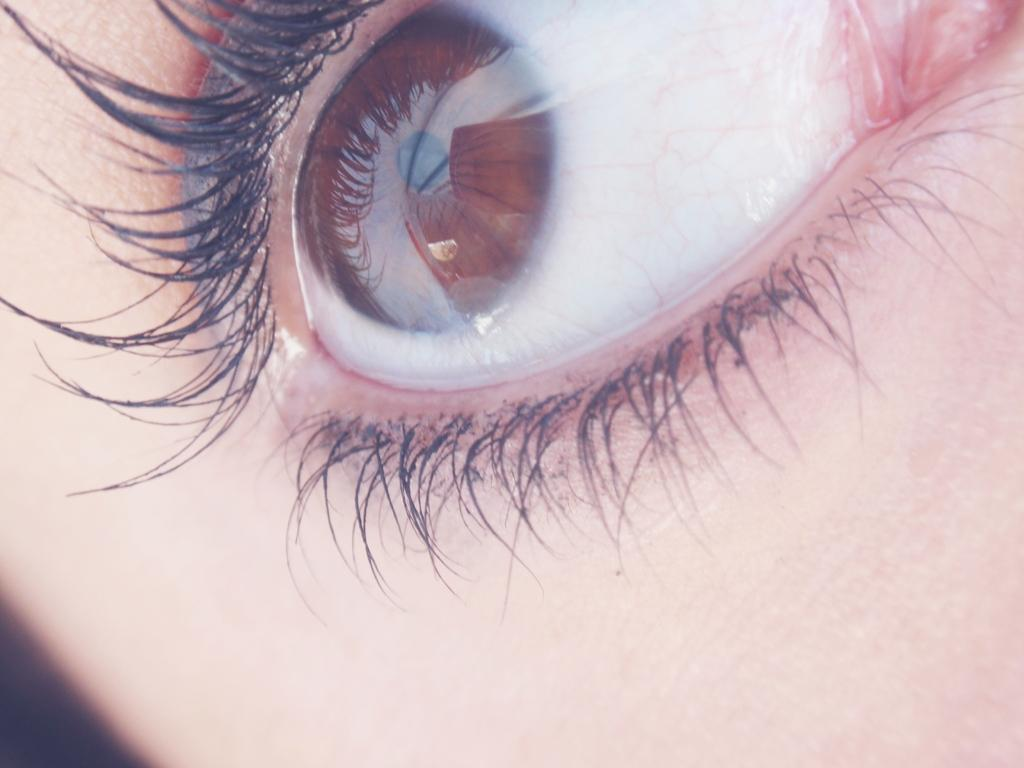What is the main subject of the image? The main subject of the image is the face of a human. Can you describe any specific features of the face? Yes, the face has a big eye. What type of territory is being claimed by the eye in the image? There is no indication in the image that the eye is claiming any territory. 